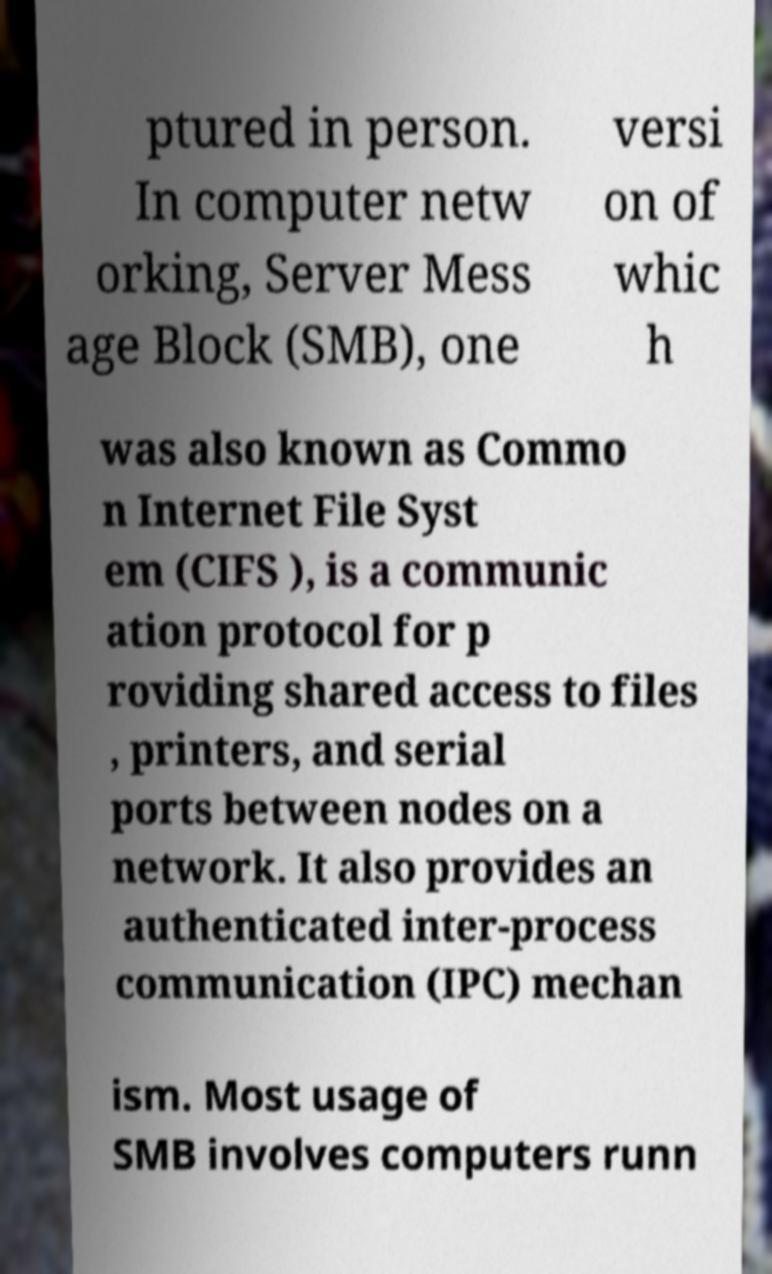Please identify and transcribe the text found in this image. ptured in person. In computer netw orking, Server Mess age Block (SMB), one versi on of whic h was also known as Commo n Internet File Syst em (CIFS ), is a communic ation protocol for p roviding shared access to files , printers, and serial ports between nodes on a network. It also provides an authenticated inter-process communication (IPC) mechan ism. Most usage of SMB involves computers runn 